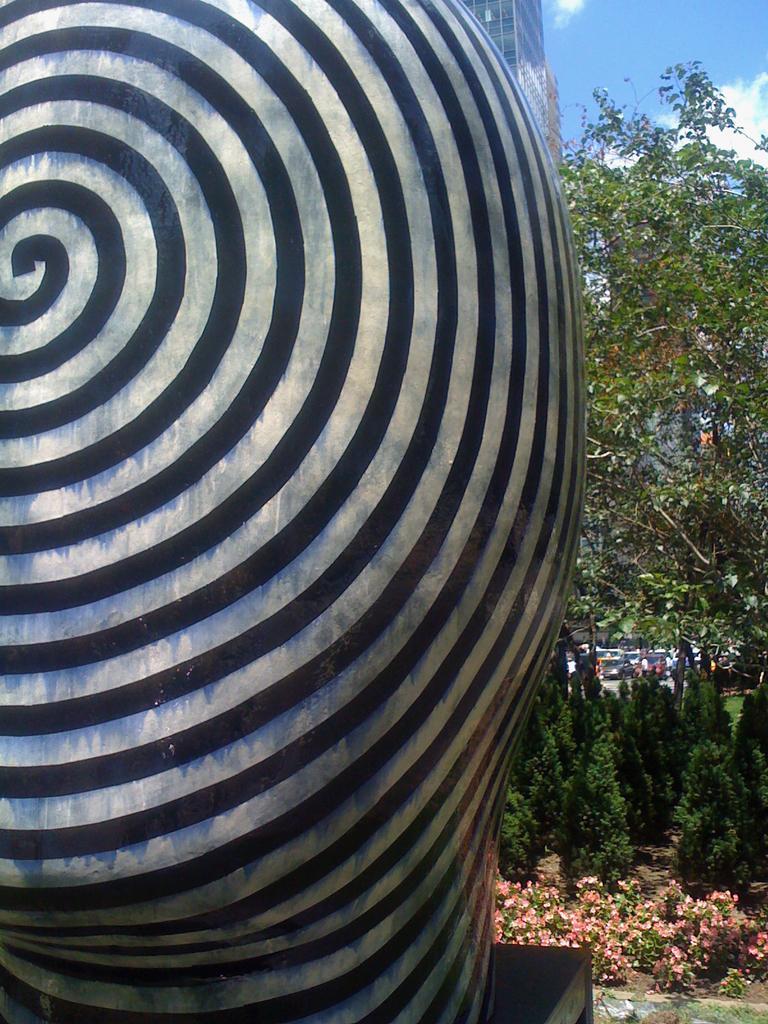Could you give a brief overview of what you see in this image? To the left side of the image there is a statue with black spiral. And to the right side of the image there are trees, plants and grass on the ground. To the top right corner of the image there is a sky. 